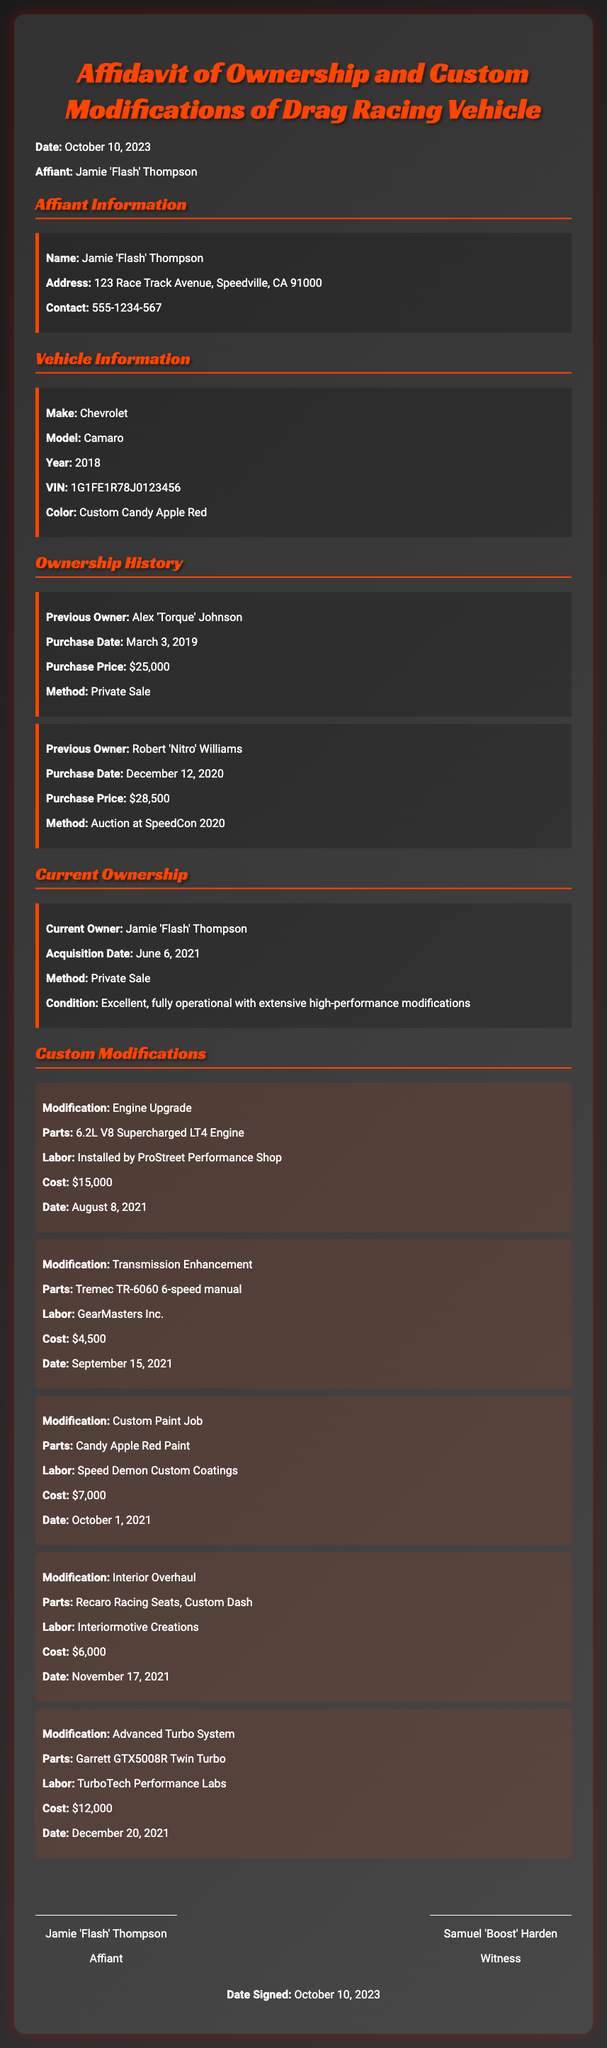What is the make of the vehicle? The make of the vehicle is specified in the Vehicle Information section, which lists Chevrolet.
Answer: Chevrolet Who signed as the witness? The witness's name is provided in the signature section of the affidavit.
Answer: Samuel 'Boost' Harden When was the engine upgrade completed? The date for the engine upgrade is given in the Custom Modifications section.
Answer: August 8, 2021 What was the purchase price from the auction? The purchase price from the auction is detailed in the Ownership History section under a Previous Owner.
Answer: $28,500 What is the color of the vehicle? The color of the vehicle is stated in the Vehicle Information section.
Answer: Custom Candy Apple Red How many previous owners does the vehicle have? The number of previous owners can be counted in the Ownership History section of the document.
Answer: 2 What is the total cost of the custom modifications listed? The total cost is the sum of all individual modification costs outlined in the Custom Modifications section.
Answer: $44,500 What condition is the vehicle currently in? The current condition of the vehicle is mentioned in the Current Ownership section.
Answer: Excellent, fully operational with extensive high-performance modifications What parts were used for the interior overhaul? The parts used for the interior overhaul are found in the related modification description.
Answer: Recaro Racing Seats, Custom Dash 